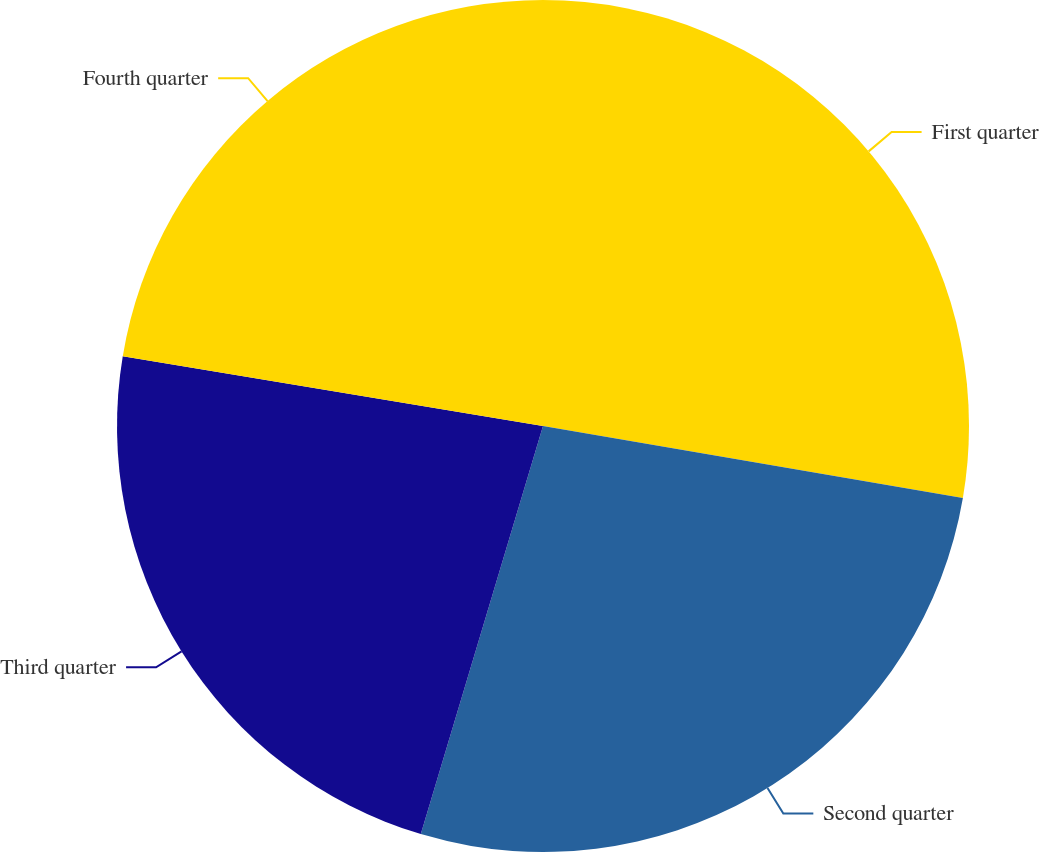<chart> <loc_0><loc_0><loc_500><loc_500><pie_chart><fcel>First quarter<fcel>Second quarter<fcel>Third quarter<fcel>Fourth quarter<nl><fcel>27.7%<fcel>26.93%<fcel>22.99%<fcel>22.38%<nl></chart> 